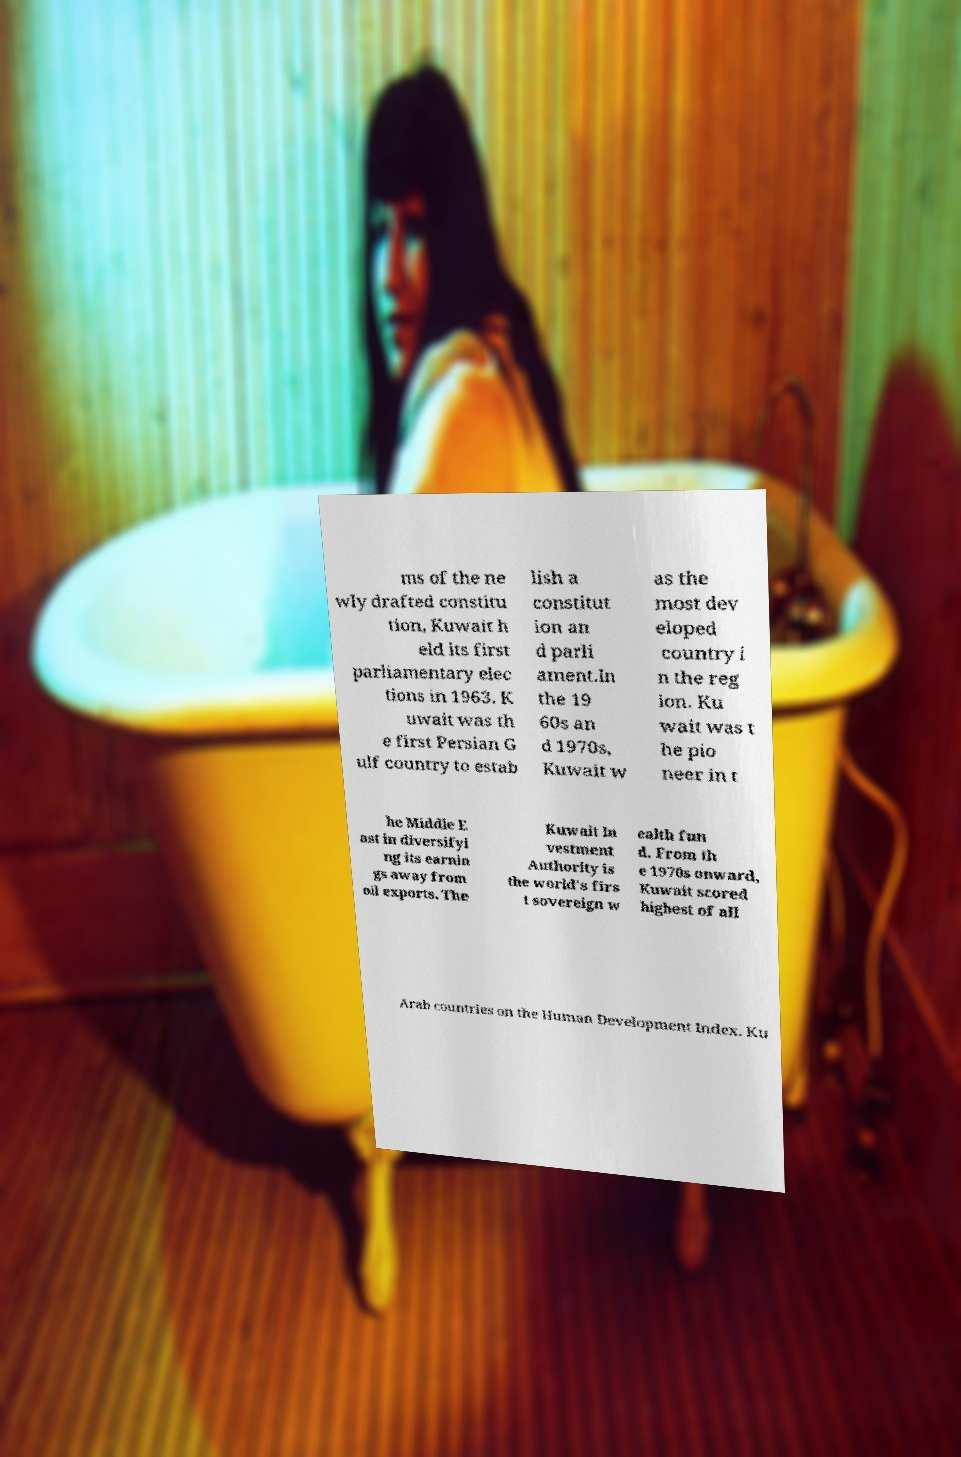There's text embedded in this image that I need extracted. Can you transcribe it verbatim? ms of the ne wly drafted constitu tion, Kuwait h eld its first parliamentary elec tions in 1963. K uwait was th e first Persian G ulf country to estab lish a constitut ion an d parli ament.In the 19 60s an d 1970s, Kuwait w as the most dev eloped country i n the reg ion. Ku wait was t he pio neer in t he Middle E ast in diversifyi ng its earnin gs away from oil exports. The Kuwait In vestment Authority is the world's firs t sovereign w ealth fun d. From th e 1970s onward, Kuwait scored highest of all Arab countries on the Human Development Index. Ku 